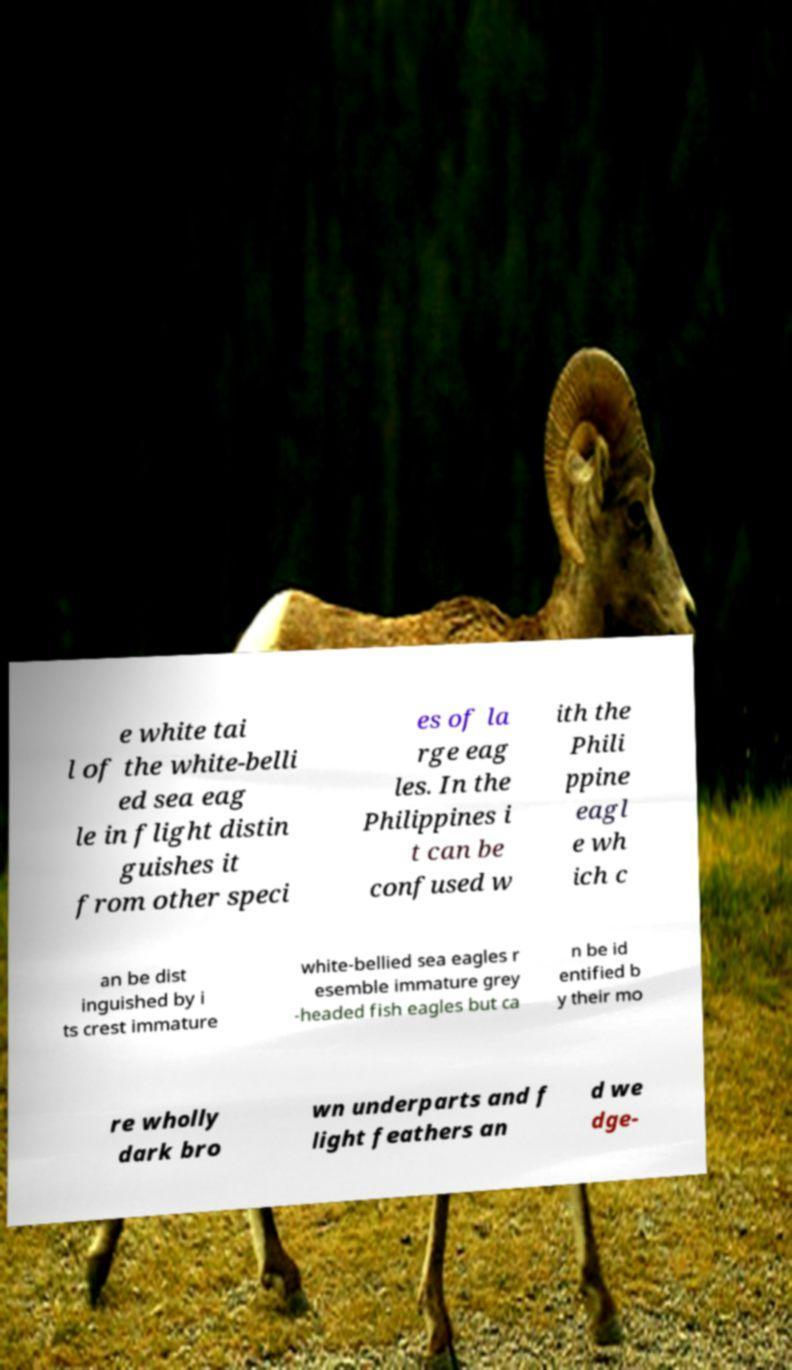Can you read and provide the text displayed in the image?This photo seems to have some interesting text. Can you extract and type it out for me? e white tai l of the white-belli ed sea eag le in flight distin guishes it from other speci es of la rge eag les. In the Philippines i t can be confused w ith the Phili ppine eagl e wh ich c an be dist inguished by i ts crest immature white-bellied sea eagles r esemble immature grey -headed fish eagles but ca n be id entified b y their mo re wholly dark bro wn underparts and f light feathers an d we dge- 